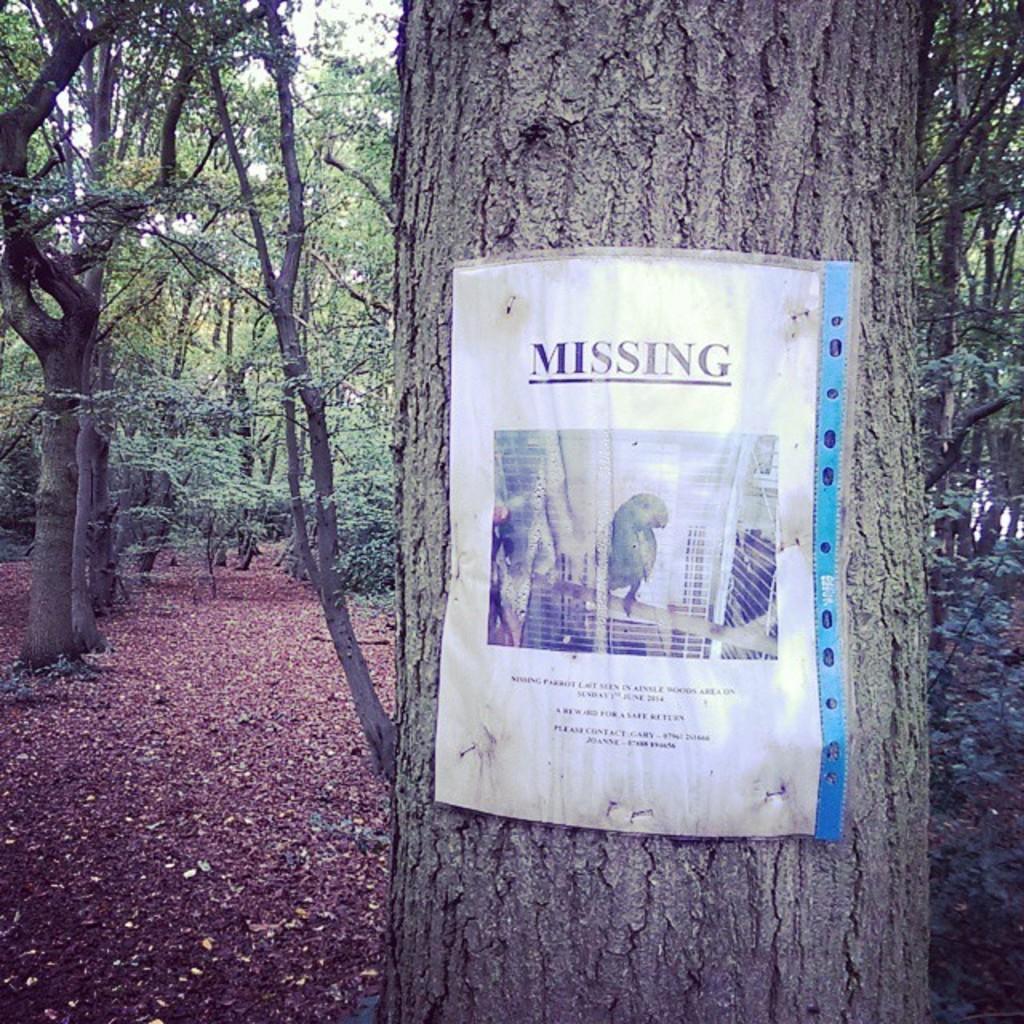How would you summarize this image in a sentence or two? In this image in the front there is a tree trunk and on the tree trunk there is a paper with some text and images on it. In the background there are trees and there are dry leaves on the ground. 